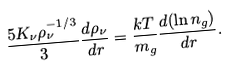Convert formula to latex. <formula><loc_0><loc_0><loc_500><loc_500>\frac { 5 K _ { \nu } \rho _ { \nu } ^ { - 1 / 3 } } { 3 } \frac { d \rho _ { \nu } } { d r } = \frac { k T } { m _ { g } } \frac { d ( \ln { n _ { g } } ) } { d r } .</formula> 